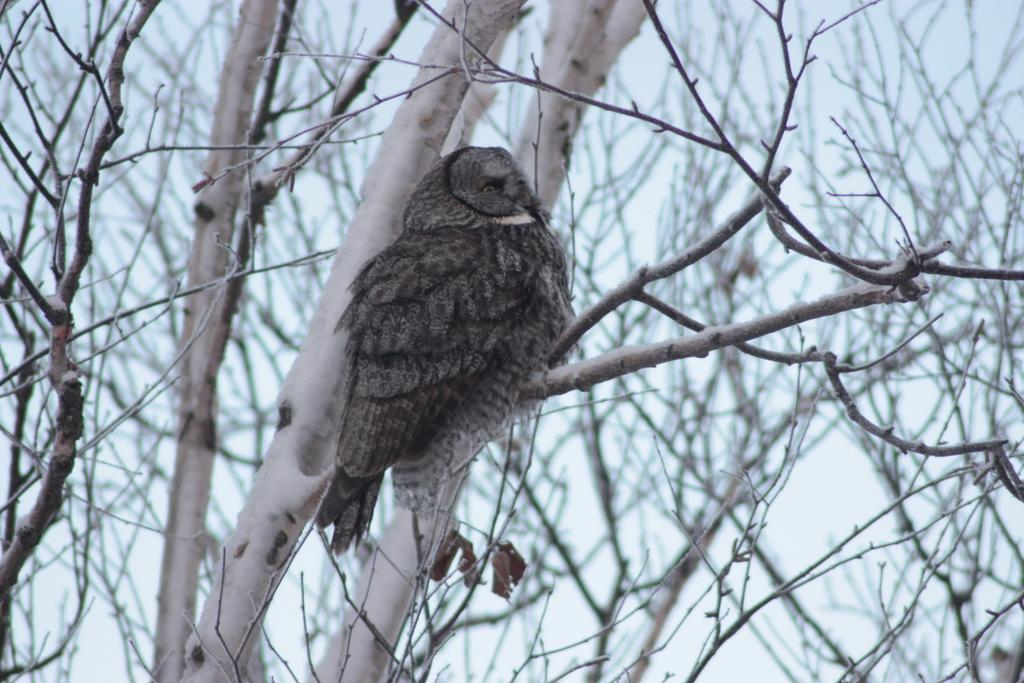What type of animal can be seen in the image? There is a bird in the image. Where is the bird located? The bird is on a branch. What else can be seen in the image besides the bird? There are trees and the sky visible in the image. What type of pet is the bird spying on with the key in the image? There is no pet, spy, or key present in the image. The image only features a bird on a branch with trees and the sky visible in the background. 